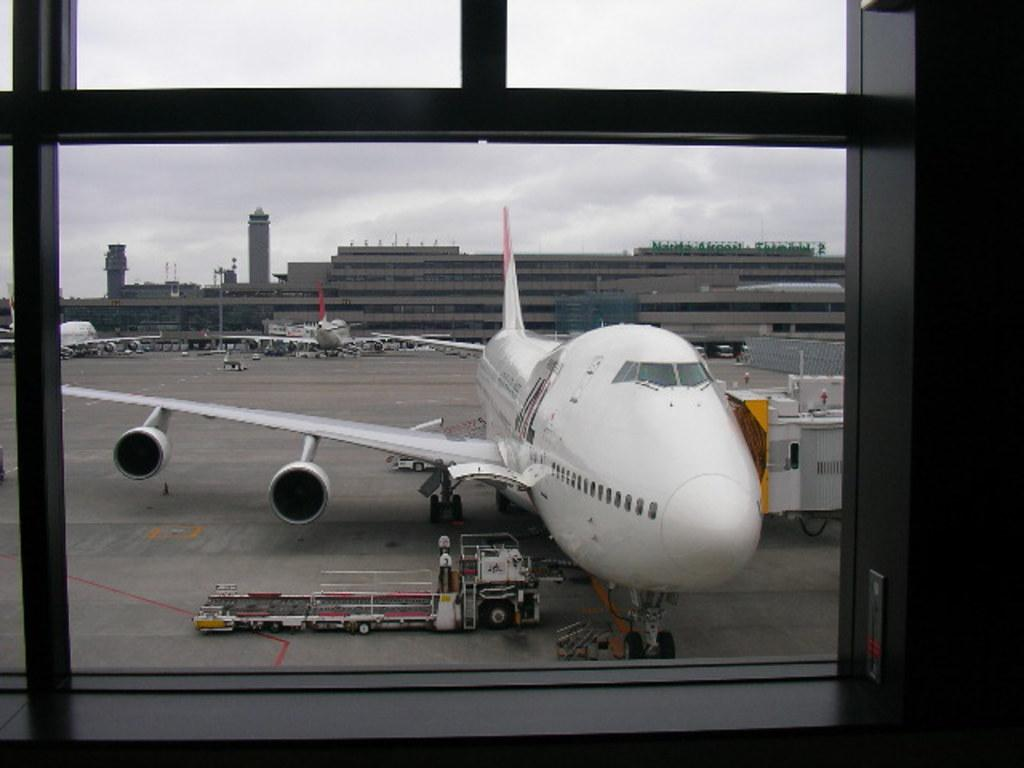What is the main subject of the image? The main subject of the image is airplanes. What other objects or vehicles can be seen in the image? There is a truck at the bottom of the image. What can be seen in the background of the image? There are buildings in the background of the image. What is visible at the top of the image? The sky is visible at the top of the image. Can you see the ocean in the image? No, the ocean is not present in the image. The image features airplanes, a truck, buildings, and the sky, but no ocean. 